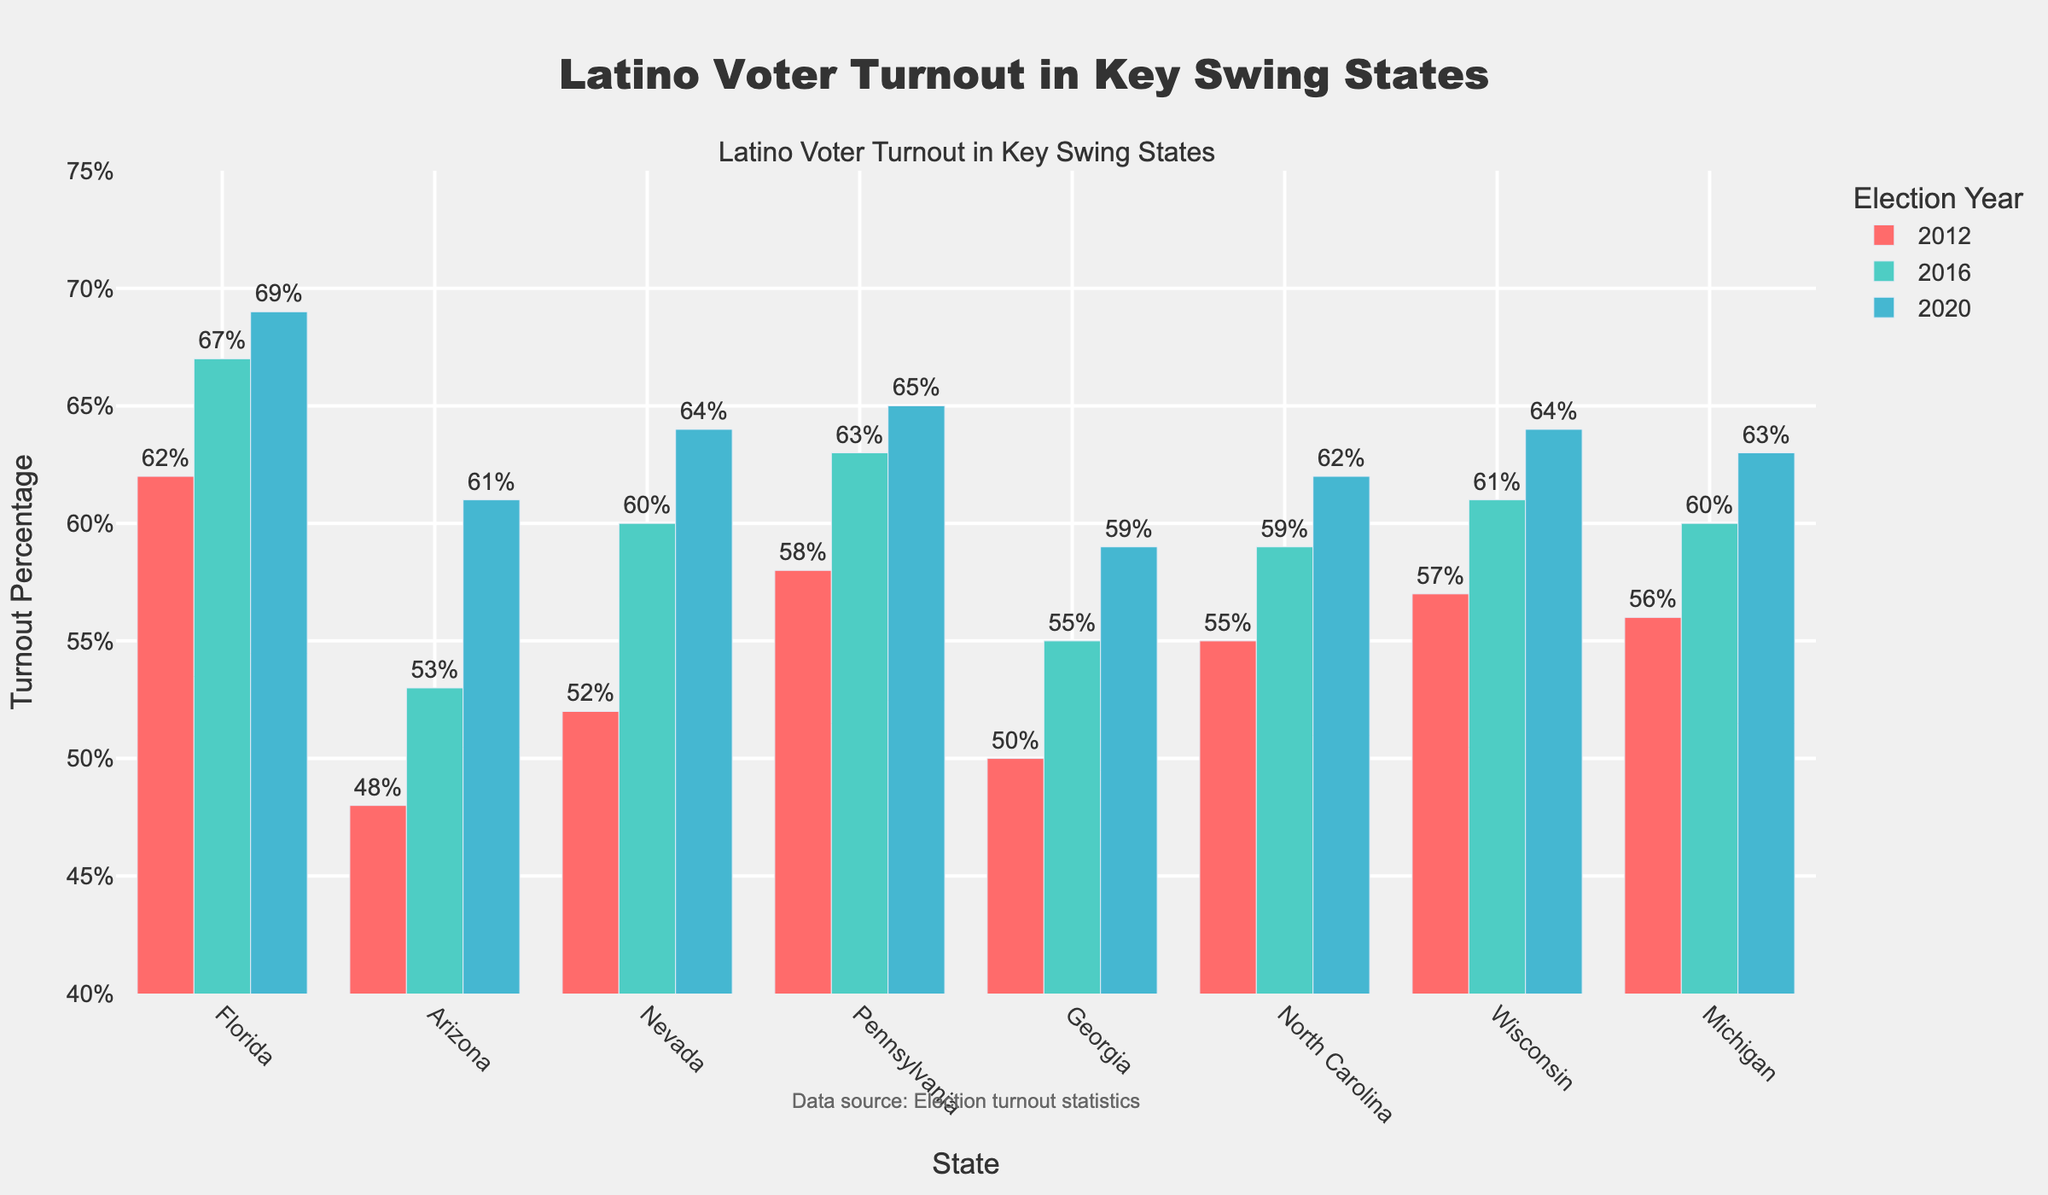What was the difference in Latino voter turnout in Florida between 2012 and 2020? To find the difference, subtract the percentage in 2012 (62%) from the percentage in 2020 (69%). So, 69% - 62% = 7%.
Answer: 7% Which state had the highest Latino voter turnout in 2016? By looking at the heights of the bars for 2016, Pennsylvania had the highest voter turnout at 63%.
Answer: Pennsylvania What was the average Latino voter turnout in the three election years (2012, 2016, 2020) for Wisconsin? Add the percentages for Wisconsin: 57% + 61% + 64%, then divide by 3. So, (57+61+64)/3 = 60.67%.
Answer: 60.67% Compare the Latino voter turnout in Arizona and Georgia in 2020. Which state had a higher turnout? By looking at the heights of the bars for 2020, Arizona had a turnout of 61%, and Georgia had 59%. Therefore, Arizona had a higher turnout.
Answer: Arizona Is there a year where Latino voter turnout in Florida surpassed 65%? By examining the bar heights for Florida in each election year, the turnout in both 2016 and 2020 were above 65% (67% and 69% respectively).
Answer: Yes What is the overall trend in Latino voter turnout in Nevada from 2012 to 2020? By observing the ascending height of the bars, the trend shows an increase from 52% in 2012 to 60% in 2016, and then to 64% in 2020.
Answer: Increasing Which state had the least significant increase in Latino voter turnout from 2012 to 2020? Calculate the increase for each state and compare. Florida: 69%-62%=7%, Arizona: 61%-48%=13%, Nevada: 64%-52%=12%, Pennsylvania: 65%-58%=7%, Georgia: 59%-50%=9%, North Carolina: 62%-55%=7%, Wisconsin: 64%-57%=7%, Michigan: 63%-56%=7%. Florida, Pennsylvania, North Carolina, Wisconsin, and Michigan all had the smallest increase of 7%.
Answer: Florida, Pennsylvania, North Carolina, Wisconsin, and Michigan What is the combined Latino voter turnout across all states in 2020? Add the percentages for each state in 2020: 69% (Florida) + 61% (Arizona) + 64% (Nevada) + 65% (Pennsylvania) + 59% (Georgia) + 62% (North Carolina) + 64% (Wisconsin) + 63% (Michigan) = 507%.
Answer: 507% From 2016 to 2020, which state showed the largest decrease in Latino voter turnout? By looking at changes from 2016 to 2020 for each state, none showed a decrease; all states showed an increase in turnout.
Answer: None Among the states listed, which one had the closest Latino voter turnout in 2016 and 2020? Compare the difference for each state: Florida: 69%-67%=2%, Arizona: 61%-53%=8%, Nevada: 64%-60%=4%, Pennsylvania: 65%-63%=2%, Georgia: 59%-55%=4%, North Carolina: 62%-59%=3%, Wisconsin: 64%-61%=3%, Michigan: 63%-60%=3%. Florida and Pennsylvania had the closest turnout difference of 2%.
Answer: Florida and Pennsylvania 